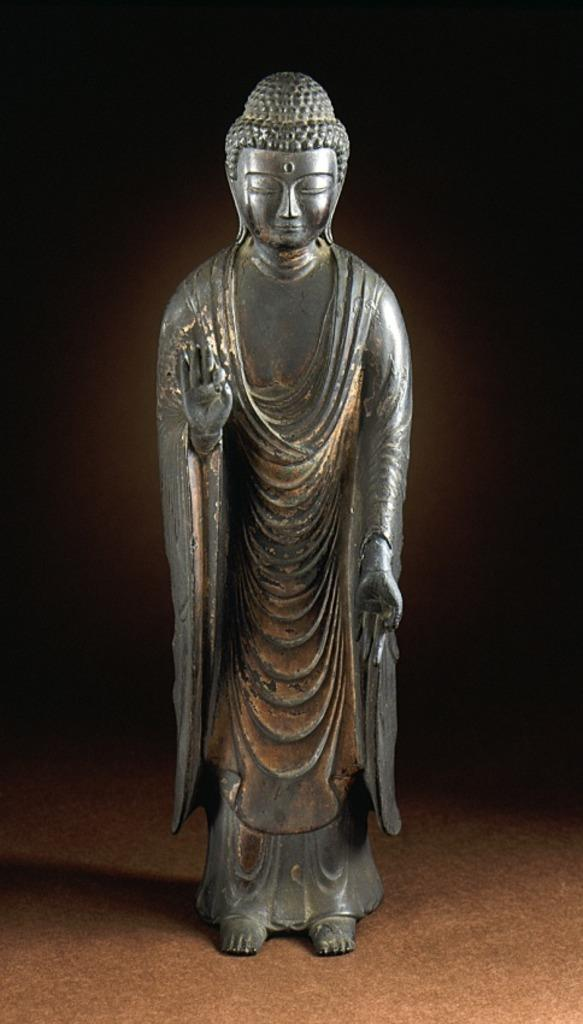What is the main subject of the image? There is a metal statue of Gautama Buddha in the image. What can be observed about the background of the image? The background of the image is dark. Where is the statue placed in the image? The statue is kept on the floor. What type of sound can be heard coming from the statue in the image? There is no sound coming from the statue in the image, as it is a statue and not capable of producing sound. 